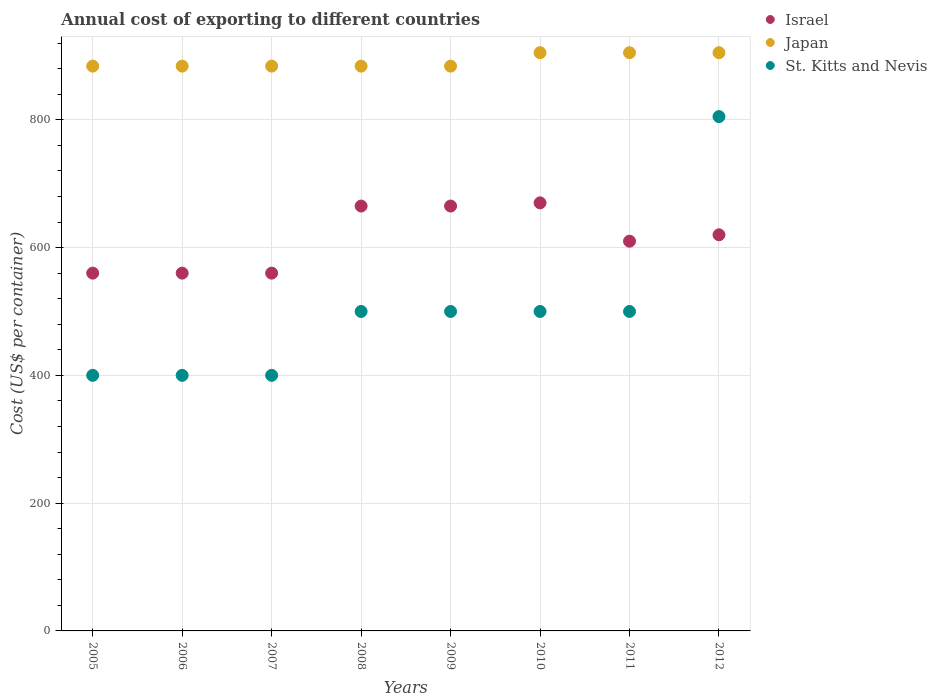What is the total annual cost of exporting in St. Kitts and Nevis in 2010?
Ensure brevity in your answer.  500. Across all years, what is the maximum total annual cost of exporting in Japan?
Your answer should be very brief. 905. Across all years, what is the minimum total annual cost of exporting in Japan?
Provide a short and direct response. 884. In which year was the total annual cost of exporting in Japan maximum?
Provide a succinct answer. 2010. What is the total total annual cost of exporting in St. Kitts and Nevis in the graph?
Offer a terse response. 4005. What is the difference between the total annual cost of exporting in Israel in 2009 and that in 2010?
Offer a very short reply. -5. What is the difference between the total annual cost of exporting in Japan in 2011 and the total annual cost of exporting in St. Kitts and Nevis in 2012?
Make the answer very short. 100. What is the average total annual cost of exporting in Israel per year?
Keep it short and to the point. 613.75. In the year 2009, what is the difference between the total annual cost of exporting in Israel and total annual cost of exporting in Japan?
Ensure brevity in your answer.  -219. Is the total annual cost of exporting in St. Kitts and Nevis in 2007 less than that in 2010?
Offer a terse response. Yes. Is the difference between the total annual cost of exporting in Israel in 2009 and 2011 greater than the difference between the total annual cost of exporting in Japan in 2009 and 2011?
Give a very brief answer. Yes. What is the difference between the highest and the lowest total annual cost of exporting in St. Kitts and Nevis?
Your response must be concise. 405. In how many years, is the total annual cost of exporting in Israel greater than the average total annual cost of exporting in Israel taken over all years?
Give a very brief answer. 4. Is it the case that in every year, the sum of the total annual cost of exporting in Japan and total annual cost of exporting in Israel  is greater than the total annual cost of exporting in St. Kitts and Nevis?
Your answer should be very brief. Yes. Does the total annual cost of exporting in St. Kitts and Nevis monotonically increase over the years?
Provide a short and direct response. No. How many dotlines are there?
Offer a very short reply. 3. Does the graph contain any zero values?
Keep it short and to the point. No. How many legend labels are there?
Make the answer very short. 3. How are the legend labels stacked?
Your response must be concise. Vertical. What is the title of the graph?
Your answer should be very brief. Annual cost of exporting to different countries. Does "South Africa" appear as one of the legend labels in the graph?
Offer a terse response. No. What is the label or title of the X-axis?
Your answer should be compact. Years. What is the label or title of the Y-axis?
Provide a succinct answer. Cost (US$ per container). What is the Cost (US$ per container) in Israel in 2005?
Provide a succinct answer. 560. What is the Cost (US$ per container) of Japan in 2005?
Your answer should be compact. 884. What is the Cost (US$ per container) in St. Kitts and Nevis in 2005?
Provide a short and direct response. 400. What is the Cost (US$ per container) in Israel in 2006?
Make the answer very short. 560. What is the Cost (US$ per container) of Japan in 2006?
Ensure brevity in your answer.  884. What is the Cost (US$ per container) in St. Kitts and Nevis in 2006?
Keep it short and to the point. 400. What is the Cost (US$ per container) in Israel in 2007?
Provide a short and direct response. 560. What is the Cost (US$ per container) in Japan in 2007?
Your answer should be very brief. 884. What is the Cost (US$ per container) in St. Kitts and Nevis in 2007?
Your answer should be very brief. 400. What is the Cost (US$ per container) in Israel in 2008?
Make the answer very short. 665. What is the Cost (US$ per container) in Japan in 2008?
Offer a very short reply. 884. What is the Cost (US$ per container) of Israel in 2009?
Keep it short and to the point. 665. What is the Cost (US$ per container) in Japan in 2009?
Offer a very short reply. 884. What is the Cost (US$ per container) of Israel in 2010?
Offer a terse response. 670. What is the Cost (US$ per container) in Japan in 2010?
Give a very brief answer. 905. What is the Cost (US$ per container) in St. Kitts and Nevis in 2010?
Provide a short and direct response. 500. What is the Cost (US$ per container) of Israel in 2011?
Make the answer very short. 610. What is the Cost (US$ per container) of Japan in 2011?
Make the answer very short. 905. What is the Cost (US$ per container) in Israel in 2012?
Provide a short and direct response. 620. What is the Cost (US$ per container) of Japan in 2012?
Ensure brevity in your answer.  905. What is the Cost (US$ per container) of St. Kitts and Nevis in 2012?
Give a very brief answer. 805. Across all years, what is the maximum Cost (US$ per container) of Israel?
Your response must be concise. 670. Across all years, what is the maximum Cost (US$ per container) in Japan?
Your answer should be very brief. 905. Across all years, what is the maximum Cost (US$ per container) of St. Kitts and Nevis?
Your answer should be compact. 805. Across all years, what is the minimum Cost (US$ per container) in Israel?
Your answer should be compact. 560. Across all years, what is the minimum Cost (US$ per container) of Japan?
Make the answer very short. 884. Across all years, what is the minimum Cost (US$ per container) of St. Kitts and Nevis?
Your answer should be very brief. 400. What is the total Cost (US$ per container) of Israel in the graph?
Provide a short and direct response. 4910. What is the total Cost (US$ per container) of Japan in the graph?
Your answer should be compact. 7135. What is the total Cost (US$ per container) in St. Kitts and Nevis in the graph?
Give a very brief answer. 4005. What is the difference between the Cost (US$ per container) of Israel in 2005 and that in 2006?
Your answer should be very brief. 0. What is the difference between the Cost (US$ per container) of Japan in 2005 and that in 2006?
Give a very brief answer. 0. What is the difference between the Cost (US$ per container) in St. Kitts and Nevis in 2005 and that in 2007?
Ensure brevity in your answer.  0. What is the difference between the Cost (US$ per container) of Israel in 2005 and that in 2008?
Your answer should be compact. -105. What is the difference between the Cost (US$ per container) of Japan in 2005 and that in 2008?
Give a very brief answer. 0. What is the difference between the Cost (US$ per container) of St. Kitts and Nevis in 2005 and that in 2008?
Your answer should be compact. -100. What is the difference between the Cost (US$ per container) of Israel in 2005 and that in 2009?
Your response must be concise. -105. What is the difference between the Cost (US$ per container) of St. Kitts and Nevis in 2005 and that in 2009?
Provide a succinct answer. -100. What is the difference between the Cost (US$ per container) of Israel in 2005 and that in 2010?
Your answer should be compact. -110. What is the difference between the Cost (US$ per container) of St. Kitts and Nevis in 2005 and that in 2010?
Make the answer very short. -100. What is the difference between the Cost (US$ per container) in St. Kitts and Nevis in 2005 and that in 2011?
Offer a very short reply. -100. What is the difference between the Cost (US$ per container) in Israel in 2005 and that in 2012?
Your response must be concise. -60. What is the difference between the Cost (US$ per container) in St. Kitts and Nevis in 2005 and that in 2012?
Give a very brief answer. -405. What is the difference between the Cost (US$ per container) in Israel in 2006 and that in 2007?
Make the answer very short. 0. What is the difference between the Cost (US$ per container) in Japan in 2006 and that in 2007?
Your response must be concise. 0. What is the difference between the Cost (US$ per container) of Israel in 2006 and that in 2008?
Provide a succinct answer. -105. What is the difference between the Cost (US$ per container) in Japan in 2006 and that in 2008?
Keep it short and to the point. 0. What is the difference between the Cost (US$ per container) in St. Kitts and Nevis in 2006 and that in 2008?
Offer a terse response. -100. What is the difference between the Cost (US$ per container) of Israel in 2006 and that in 2009?
Your response must be concise. -105. What is the difference between the Cost (US$ per container) of Japan in 2006 and that in 2009?
Offer a very short reply. 0. What is the difference between the Cost (US$ per container) in St. Kitts and Nevis in 2006 and that in 2009?
Offer a very short reply. -100. What is the difference between the Cost (US$ per container) of Israel in 2006 and that in 2010?
Keep it short and to the point. -110. What is the difference between the Cost (US$ per container) in St. Kitts and Nevis in 2006 and that in 2010?
Keep it short and to the point. -100. What is the difference between the Cost (US$ per container) in Israel in 2006 and that in 2011?
Your response must be concise. -50. What is the difference between the Cost (US$ per container) in St. Kitts and Nevis in 2006 and that in 2011?
Ensure brevity in your answer.  -100. What is the difference between the Cost (US$ per container) in Israel in 2006 and that in 2012?
Offer a terse response. -60. What is the difference between the Cost (US$ per container) in St. Kitts and Nevis in 2006 and that in 2012?
Give a very brief answer. -405. What is the difference between the Cost (US$ per container) in Israel in 2007 and that in 2008?
Ensure brevity in your answer.  -105. What is the difference between the Cost (US$ per container) in St. Kitts and Nevis in 2007 and that in 2008?
Make the answer very short. -100. What is the difference between the Cost (US$ per container) of Israel in 2007 and that in 2009?
Keep it short and to the point. -105. What is the difference between the Cost (US$ per container) of Japan in 2007 and that in 2009?
Your answer should be very brief. 0. What is the difference between the Cost (US$ per container) of St. Kitts and Nevis in 2007 and that in 2009?
Provide a succinct answer. -100. What is the difference between the Cost (US$ per container) in Israel in 2007 and that in 2010?
Offer a very short reply. -110. What is the difference between the Cost (US$ per container) of Japan in 2007 and that in 2010?
Make the answer very short. -21. What is the difference between the Cost (US$ per container) of St. Kitts and Nevis in 2007 and that in 2010?
Your answer should be compact. -100. What is the difference between the Cost (US$ per container) in Israel in 2007 and that in 2011?
Your answer should be compact. -50. What is the difference between the Cost (US$ per container) of Japan in 2007 and that in 2011?
Make the answer very short. -21. What is the difference between the Cost (US$ per container) of St. Kitts and Nevis in 2007 and that in 2011?
Make the answer very short. -100. What is the difference between the Cost (US$ per container) in Israel in 2007 and that in 2012?
Offer a very short reply. -60. What is the difference between the Cost (US$ per container) of St. Kitts and Nevis in 2007 and that in 2012?
Keep it short and to the point. -405. What is the difference between the Cost (US$ per container) of Israel in 2008 and that in 2009?
Your answer should be compact. 0. What is the difference between the Cost (US$ per container) in Japan in 2008 and that in 2009?
Your answer should be very brief. 0. What is the difference between the Cost (US$ per container) in St. Kitts and Nevis in 2008 and that in 2009?
Ensure brevity in your answer.  0. What is the difference between the Cost (US$ per container) of Israel in 2008 and that in 2010?
Offer a terse response. -5. What is the difference between the Cost (US$ per container) of Japan in 2008 and that in 2010?
Provide a short and direct response. -21. What is the difference between the Cost (US$ per container) of Japan in 2008 and that in 2011?
Keep it short and to the point. -21. What is the difference between the Cost (US$ per container) in St. Kitts and Nevis in 2008 and that in 2011?
Provide a succinct answer. 0. What is the difference between the Cost (US$ per container) of St. Kitts and Nevis in 2008 and that in 2012?
Keep it short and to the point. -305. What is the difference between the Cost (US$ per container) in Israel in 2009 and that in 2010?
Offer a terse response. -5. What is the difference between the Cost (US$ per container) in Japan in 2009 and that in 2010?
Keep it short and to the point. -21. What is the difference between the Cost (US$ per container) in Israel in 2009 and that in 2011?
Provide a succinct answer. 55. What is the difference between the Cost (US$ per container) in Japan in 2009 and that in 2011?
Give a very brief answer. -21. What is the difference between the Cost (US$ per container) of St. Kitts and Nevis in 2009 and that in 2011?
Provide a succinct answer. 0. What is the difference between the Cost (US$ per container) in Israel in 2009 and that in 2012?
Your answer should be very brief. 45. What is the difference between the Cost (US$ per container) of St. Kitts and Nevis in 2009 and that in 2012?
Give a very brief answer. -305. What is the difference between the Cost (US$ per container) of Israel in 2010 and that in 2011?
Provide a succinct answer. 60. What is the difference between the Cost (US$ per container) of Japan in 2010 and that in 2011?
Your answer should be compact. 0. What is the difference between the Cost (US$ per container) in Israel in 2010 and that in 2012?
Provide a short and direct response. 50. What is the difference between the Cost (US$ per container) of Japan in 2010 and that in 2012?
Provide a short and direct response. 0. What is the difference between the Cost (US$ per container) of St. Kitts and Nevis in 2010 and that in 2012?
Offer a terse response. -305. What is the difference between the Cost (US$ per container) of St. Kitts and Nevis in 2011 and that in 2012?
Your answer should be very brief. -305. What is the difference between the Cost (US$ per container) of Israel in 2005 and the Cost (US$ per container) of Japan in 2006?
Your answer should be compact. -324. What is the difference between the Cost (US$ per container) in Israel in 2005 and the Cost (US$ per container) in St. Kitts and Nevis in 2006?
Ensure brevity in your answer.  160. What is the difference between the Cost (US$ per container) of Japan in 2005 and the Cost (US$ per container) of St. Kitts and Nevis in 2006?
Your answer should be very brief. 484. What is the difference between the Cost (US$ per container) of Israel in 2005 and the Cost (US$ per container) of Japan in 2007?
Offer a very short reply. -324. What is the difference between the Cost (US$ per container) in Israel in 2005 and the Cost (US$ per container) in St. Kitts and Nevis in 2007?
Offer a terse response. 160. What is the difference between the Cost (US$ per container) in Japan in 2005 and the Cost (US$ per container) in St. Kitts and Nevis in 2007?
Ensure brevity in your answer.  484. What is the difference between the Cost (US$ per container) of Israel in 2005 and the Cost (US$ per container) of Japan in 2008?
Provide a short and direct response. -324. What is the difference between the Cost (US$ per container) of Israel in 2005 and the Cost (US$ per container) of St. Kitts and Nevis in 2008?
Provide a succinct answer. 60. What is the difference between the Cost (US$ per container) in Japan in 2005 and the Cost (US$ per container) in St. Kitts and Nevis in 2008?
Keep it short and to the point. 384. What is the difference between the Cost (US$ per container) of Israel in 2005 and the Cost (US$ per container) of Japan in 2009?
Your response must be concise. -324. What is the difference between the Cost (US$ per container) in Japan in 2005 and the Cost (US$ per container) in St. Kitts and Nevis in 2009?
Keep it short and to the point. 384. What is the difference between the Cost (US$ per container) in Israel in 2005 and the Cost (US$ per container) in Japan in 2010?
Ensure brevity in your answer.  -345. What is the difference between the Cost (US$ per container) of Japan in 2005 and the Cost (US$ per container) of St. Kitts and Nevis in 2010?
Your answer should be compact. 384. What is the difference between the Cost (US$ per container) of Israel in 2005 and the Cost (US$ per container) of Japan in 2011?
Ensure brevity in your answer.  -345. What is the difference between the Cost (US$ per container) in Israel in 2005 and the Cost (US$ per container) in St. Kitts and Nevis in 2011?
Keep it short and to the point. 60. What is the difference between the Cost (US$ per container) in Japan in 2005 and the Cost (US$ per container) in St. Kitts and Nevis in 2011?
Offer a terse response. 384. What is the difference between the Cost (US$ per container) in Israel in 2005 and the Cost (US$ per container) in Japan in 2012?
Offer a terse response. -345. What is the difference between the Cost (US$ per container) in Israel in 2005 and the Cost (US$ per container) in St. Kitts and Nevis in 2012?
Provide a short and direct response. -245. What is the difference between the Cost (US$ per container) of Japan in 2005 and the Cost (US$ per container) of St. Kitts and Nevis in 2012?
Ensure brevity in your answer.  79. What is the difference between the Cost (US$ per container) of Israel in 2006 and the Cost (US$ per container) of Japan in 2007?
Offer a very short reply. -324. What is the difference between the Cost (US$ per container) in Israel in 2006 and the Cost (US$ per container) in St. Kitts and Nevis in 2007?
Your answer should be very brief. 160. What is the difference between the Cost (US$ per container) of Japan in 2006 and the Cost (US$ per container) of St. Kitts and Nevis in 2007?
Provide a succinct answer. 484. What is the difference between the Cost (US$ per container) in Israel in 2006 and the Cost (US$ per container) in Japan in 2008?
Provide a succinct answer. -324. What is the difference between the Cost (US$ per container) in Japan in 2006 and the Cost (US$ per container) in St. Kitts and Nevis in 2008?
Make the answer very short. 384. What is the difference between the Cost (US$ per container) of Israel in 2006 and the Cost (US$ per container) of Japan in 2009?
Your answer should be compact. -324. What is the difference between the Cost (US$ per container) in Japan in 2006 and the Cost (US$ per container) in St. Kitts and Nevis in 2009?
Make the answer very short. 384. What is the difference between the Cost (US$ per container) of Israel in 2006 and the Cost (US$ per container) of Japan in 2010?
Keep it short and to the point. -345. What is the difference between the Cost (US$ per container) of Japan in 2006 and the Cost (US$ per container) of St. Kitts and Nevis in 2010?
Ensure brevity in your answer.  384. What is the difference between the Cost (US$ per container) of Israel in 2006 and the Cost (US$ per container) of Japan in 2011?
Give a very brief answer. -345. What is the difference between the Cost (US$ per container) in Israel in 2006 and the Cost (US$ per container) in St. Kitts and Nevis in 2011?
Your answer should be very brief. 60. What is the difference between the Cost (US$ per container) in Japan in 2006 and the Cost (US$ per container) in St. Kitts and Nevis in 2011?
Provide a succinct answer. 384. What is the difference between the Cost (US$ per container) of Israel in 2006 and the Cost (US$ per container) of Japan in 2012?
Offer a terse response. -345. What is the difference between the Cost (US$ per container) in Israel in 2006 and the Cost (US$ per container) in St. Kitts and Nevis in 2012?
Your answer should be very brief. -245. What is the difference between the Cost (US$ per container) in Japan in 2006 and the Cost (US$ per container) in St. Kitts and Nevis in 2012?
Your answer should be very brief. 79. What is the difference between the Cost (US$ per container) of Israel in 2007 and the Cost (US$ per container) of Japan in 2008?
Your response must be concise. -324. What is the difference between the Cost (US$ per container) of Japan in 2007 and the Cost (US$ per container) of St. Kitts and Nevis in 2008?
Provide a succinct answer. 384. What is the difference between the Cost (US$ per container) in Israel in 2007 and the Cost (US$ per container) in Japan in 2009?
Provide a short and direct response. -324. What is the difference between the Cost (US$ per container) in Japan in 2007 and the Cost (US$ per container) in St. Kitts and Nevis in 2009?
Your answer should be very brief. 384. What is the difference between the Cost (US$ per container) in Israel in 2007 and the Cost (US$ per container) in Japan in 2010?
Offer a very short reply. -345. What is the difference between the Cost (US$ per container) of Israel in 2007 and the Cost (US$ per container) of St. Kitts and Nevis in 2010?
Ensure brevity in your answer.  60. What is the difference between the Cost (US$ per container) of Japan in 2007 and the Cost (US$ per container) of St. Kitts and Nevis in 2010?
Provide a succinct answer. 384. What is the difference between the Cost (US$ per container) in Israel in 2007 and the Cost (US$ per container) in Japan in 2011?
Your response must be concise. -345. What is the difference between the Cost (US$ per container) in Japan in 2007 and the Cost (US$ per container) in St. Kitts and Nevis in 2011?
Ensure brevity in your answer.  384. What is the difference between the Cost (US$ per container) of Israel in 2007 and the Cost (US$ per container) of Japan in 2012?
Your answer should be very brief. -345. What is the difference between the Cost (US$ per container) in Israel in 2007 and the Cost (US$ per container) in St. Kitts and Nevis in 2012?
Your answer should be compact. -245. What is the difference between the Cost (US$ per container) of Japan in 2007 and the Cost (US$ per container) of St. Kitts and Nevis in 2012?
Provide a short and direct response. 79. What is the difference between the Cost (US$ per container) of Israel in 2008 and the Cost (US$ per container) of Japan in 2009?
Provide a short and direct response. -219. What is the difference between the Cost (US$ per container) in Israel in 2008 and the Cost (US$ per container) in St. Kitts and Nevis in 2009?
Offer a very short reply. 165. What is the difference between the Cost (US$ per container) of Japan in 2008 and the Cost (US$ per container) of St. Kitts and Nevis in 2009?
Offer a terse response. 384. What is the difference between the Cost (US$ per container) of Israel in 2008 and the Cost (US$ per container) of Japan in 2010?
Provide a short and direct response. -240. What is the difference between the Cost (US$ per container) in Israel in 2008 and the Cost (US$ per container) in St. Kitts and Nevis in 2010?
Offer a very short reply. 165. What is the difference between the Cost (US$ per container) of Japan in 2008 and the Cost (US$ per container) of St. Kitts and Nevis in 2010?
Offer a terse response. 384. What is the difference between the Cost (US$ per container) in Israel in 2008 and the Cost (US$ per container) in Japan in 2011?
Offer a very short reply. -240. What is the difference between the Cost (US$ per container) of Israel in 2008 and the Cost (US$ per container) of St. Kitts and Nevis in 2011?
Your answer should be very brief. 165. What is the difference between the Cost (US$ per container) of Japan in 2008 and the Cost (US$ per container) of St. Kitts and Nevis in 2011?
Your answer should be very brief. 384. What is the difference between the Cost (US$ per container) of Israel in 2008 and the Cost (US$ per container) of Japan in 2012?
Your answer should be compact. -240. What is the difference between the Cost (US$ per container) of Israel in 2008 and the Cost (US$ per container) of St. Kitts and Nevis in 2012?
Offer a terse response. -140. What is the difference between the Cost (US$ per container) in Japan in 2008 and the Cost (US$ per container) in St. Kitts and Nevis in 2012?
Your answer should be very brief. 79. What is the difference between the Cost (US$ per container) in Israel in 2009 and the Cost (US$ per container) in Japan in 2010?
Offer a very short reply. -240. What is the difference between the Cost (US$ per container) in Israel in 2009 and the Cost (US$ per container) in St. Kitts and Nevis in 2010?
Provide a short and direct response. 165. What is the difference between the Cost (US$ per container) in Japan in 2009 and the Cost (US$ per container) in St. Kitts and Nevis in 2010?
Your response must be concise. 384. What is the difference between the Cost (US$ per container) of Israel in 2009 and the Cost (US$ per container) of Japan in 2011?
Your response must be concise. -240. What is the difference between the Cost (US$ per container) of Israel in 2009 and the Cost (US$ per container) of St. Kitts and Nevis in 2011?
Keep it short and to the point. 165. What is the difference between the Cost (US$ per container) in Japan in 2009 and the Cost (US$ per container) in St. Kitts and Nevis in 2011?
Your answer should be compact. 384. What is the difference between the Cost (US$ per container) of Israel in 2009 and the Cost (US$ per container) of Japan in 2012?
Provide a succinct answer. -240. What is the difference between the Cost (US$ per container) in Israel in 2009 and the Cost (US$ per container) in St. Kitts and Nevis in 2012?
Offer a terse response. -140. What is the difference between the Cost (US$ per container) of Japan in 2009 and the Cost (US$ per container) of St. Kitts and Nevis in 2012?
Your response must be concise. 79. What is the difference between the Cost (US$ per container) in Israel in 2010 and the Cost (US$ per container) in Japan in 2011?
Offer a terse response. -235. What is the difference between the Cost (US$ per container) in Israel in 2010 and the Cost (US$ per container) in St. Kitts and Nevis in 2011?
Give a very brief answer. 170. What is the difference between the Cost (US$ per container) of Japan in 2010 and the Cost (US$ per container) of St. Kitts and Nevis in 2011?
Your answer should be compact. 405. What is the difference between the Cost (US$ per container) of Israel in 2010 and the Cost (US$ per container) of Japan in 2012?
Make the answer very short. -235. What is the difference between the Cost (US$ per container) of Israel in 2010 and the Cost (US$ per container) of St. Kitts and Nevis in 2012?
Keep it short and to the point. -135. What is the difference between the Cost (US$ per container) of Japan in 2010 and the Cost (US$ per container) of St. Kitts and Nevis in 2012?
Give a very brief answer. 100. What is the difference between the Cost (US$ per container) of Israel in 2011 and the Cost (US$ per container) of Japan in 2012?
Keep it short and to the point. -295. What is the difference between the Cost (US$ per container) in Israel in 2011 and the Cost (US$ per container) in St. Kitts and Nevis in 2012?
Your answer should be very brief. -195. What is the average Cost (US$ per container) in Israel per year?
Offer a very short reply. 613.75. What is the average Cost (US$ per container) of Japan per year?
Your answer should be very brief. 891.88. What is the average Cost (US$ per container) in St. Kitts and Nevis per year?
Ensure brevity in your answer.  500.62. In the year 2005, what is the difference between the Cost (US$ per container) of Israel and Cost (US$ per container) of Japan?
Your answer should be compact. -324. In the year 2005, what is the difference between the Cost (US$ per container) of Israel and Cost (US$ per container) of St. Kitts and Nevis?
Your answer should be very brief. 160. In the year 2005, what is the difference between the Cost (US$ per container) of Japan and Cost (US$ per container) of St. Kitts and Nevis?
Give a very brief answer. 484. In the year 2006, what is the difference between the Cost (US$ per container) of Israel and Cost (US$ per container) of Japan?
Your answer should be very brief. -324. In the year 2006, what is the difference between the Cost (US$ per container) of Israel and Cost (US$ per container) of St. Kitts and Nevis?
Offer a very short reply. 160. In the year 2006, what is the difference between the Cost (US$ per container) of Japan and Cost (US$ per container) of St. Kitts and Nevis?
Your response must be concise. 484. In the year 2007, what is the difference between the Cost (US$ per container) of Israel and Cost (US$ per container) of Japan?
Your answer should be very brief. -324. In the year 2007, what is the difference between the Cost (US$ per container) of Israel and Cost (US$ per container) of St. Kitts and Nevis?
Your answer should be very brief. 160. In the year 2007, what is the difference between the Cost (US$ per container) in Japan and Cost (US$ per container) in St. Kitts and Nevis?
Your answer should be compact. 484. In the year 2008, what is the difference between the Cost (US$ per container) of Israel and Cost (US$ per container) of Japan?
Your answer should be very brief. -219. In the year 2008, what is the difference between the Cost (US$ per container) in Israel and Cost (US$ per container) in St. Kitts and Nevis?
Your answer should be very brief. 165. In the year 2008, what is the difference between the Cost (US$ per container) in Japan and Cost (US$ per container) in St. Kitts and Nevis?
Offer a very short reply. 384. In the year 2009, what is the difference between the Cost (US$ per container) of Israel and Cost (US$ per container) of Japan?
Offer a very short reply. -219. In the year 2009, what is the difference between the Cost (US$ per container) of Israel and Cost (US$ per container) of St. Kitts and Nevis?
Keep it short and to the point. 165. In the year 2009, what is the difference between the Cost (US$ per container) in Japan and Cost (US$ per container) in St. Kitts and Nevis?
Offer a terse response. 384. In the year 2010, what is the difference between the Cost (US$ per container) in Israel and Cost (US$ per container) in Japan?
Your answer should be compact. -235. In the year 2010, what is the difference between the Cost (US$ per container) of Israel and Cost (US$ per container) of St. Kitts and Nevis?
Ensure brevity in your answer.  170. In the year 2010, what is the difference between the Cost (US$ per container) of Japan and Cost (US$ per container) of St. Kitts and Nevis?
Offer a very short reply. 405. In the year 2011, what is the difference between the Cost (US$ per container) of Israel and Cost (US$ per container) of Japan?
Your response must be concise. -295. In the year 2011, what is the difference between the Cost (US$ per container) in Israel and Cost (US$ per container) in St. Kitts and Nevis?
Ensure brevity in your answer.  110. In the year 2011, what is the difference between the Cost (US$ per container) of Japan and Cost (US$ per container) of St. Kitts and Nevis?
Provide a short and direct response. 405. In the year 2012, what is the difference between the Cost (US$ per container) of Israel and Cost (US$ per container) of Japan?
Provide a short and direct response. -285. In the year 2012, what is the difference between the Cost (US$ per container) of Israel and Cost (US$ per container) of St. Kitts and Nevis?
Offer a terse response. -185. In the year 2012, what is the difference between the Cost (US$ per container) in Japan and Cost (US$ per container) in St. Kitts and Nevis?
Provide a succinct answer. 100. What is the ratio of the Cost (US$ per container) of Israel in 2005 to that in 2007?
Offer a very short reply. 1. What is the ratio of the Cost (US$ per container) of Israel in 2005 to that in 2008?
Offer a terse response. 0.84. What is the ratio of the Cost (US$ per container) of Japan in 2005 to that in 2008?
Keep it short and to the point. 1. What is the ratio of the Cost (US$ per container) in St. Kitts and Nevis in 2005 to that in 2008?
Provide a short and direct response. 0.8. What is the ratio of the Cost (US$ per container) of Israel in 2005 to that in 2009?
Ensure brevity in your answer.  0.84. What is the ratio of the Cost (US$ per container) of Japan in 2005 to that in 2009?
Make the answer very short. 1. What is the ratio of the Cost (US$ per container) of Israel in 2005 to that in 2010?
Offer a very short reply. 0.84. What is the ratio of the Cost (US$ per container) in Japan in 2005 to that in 2010?
Provide a succinct answer. 0.98. What is the ratio of the Cost (US$ per container) in Israel in 2005 to that in 2011?
Provide a succinct answer. 0.92. What is the ratio of the Cost (US$ per container) in Japan in 2005 to that in 2011?
Keep it short and to the point. 0.98. What is the ratio of the Cost (US$ per container) of Israel in 2005 to that in 2012?
Offer a terse response. 0.9. What is the ratio of the Cost (US$ per container) of Japan in 2005 to that in 2012?
Provide a short and direct response. 0.98. What is the ratio of the Cost (US$ per container) in St. Kitts and Nevis in 2005 to that in 2012?
Keep it short and to the point. 0.5. What is the ratio of the Cost (US$ per container) of Israel in 2006 to that in 2008?
Ensure brevity in your answer.  0.84. What is the ratio of the Cost (US$ per container) in St. Kitts and Nevis in 2006 to that in 2008?
Your answer should be compact. 0.8. What is the ratio of the Cost (US$ per container) in Israel in 2006 to that in 2009?
Offer a terse response. 0.84. What is the ratio of the Cost (US$ per container) in Japan in 2006 to that in 2009?
Provide a short and direct response. 1. What is the ratio of the Cost (US$ per container) of St. Kitts and Nevis in 2006 to that in 2009?
Give a very brief answer. 0.8. What is the ratio of the Cost (US$ per container) in Israel in 2006 to that in 2010?
Ensure brevity in your answer.  0.84. What is the ratio of the Cost (US$ per container) of Japan in 2006 to that in 2010?
Offer a very short reply. 0.98. What is the ratio of the Cost (US$ per container) in St. Kitts and Nevis in 2006 to that in 2010?
Provide a succinct answer. 0.8. What is the ratio of the Cost (US$ per container) in Israel in 2006 to that in 2011?
Your response must be concise. 0.92. What is the ratio of the Cost (US$ per container) of Japan in 2006 to that in 2011?
Offer a terse response. 0.98. What is the ratio of the Cost (US$ per container) of St. Kitts and Nevis in 2006 to that in 2011?
Offer a terse response. 0.8. What is the ratio of the Cost (US$ per container) in Israel in 2006 to that in 2012?
Offer a very short reply. 0.9. What is the ratio of the Cost (US$ per container) in Japan in 2006 to that in 2012?
Ensure brevity in your answer.  0.98. What is the ratio of the Cost (US$ per container) in St. Kitts and Nevis in 2006 to that in 2012?
Provide a short and direct response. 0.5. What is the ratio of the Cost (US$ per container) in Israel in 2007 to that in 2008?
Make the answer very short. 0.84. What is the ratio of the Cost (US$ per container) of Japan in 2007 to that in 2008?
Give a very brief answer. 1. What is the ratio of the Cost (US$ per container) of St. Kitts and Nevis in 2007 to that in 2008?
Keep it short and to the point. 0.8. What is the ratio of the Cost (US$ per container) in Israel in 2007 to that in 2009?
Provide a short and direct response. 0.84. What is the ratio of the Cost (US$ per container) of St. Kitts and Nevis in 2007 to that in 2009?
Offer a terse response. 0.8. What is the ratio of the Cost (US$ per container) in Israel in 2007 to that in 2010?
Give a very brief answer. 0.84. What is the ratio of the Cost (US$ per container) of Japan in 2007 to that in 2010?
Offer a very short reply. 0.98. What is the ratio of the Cost (US$ per container) in Israel in 2007 to that in 2011?
Give a very brief answer. 0.92. What is the ratio of the Cost (US$ per container) in Japan in 2007 to that in 2011?
Your answer should be very brief. 0.98. What is the ratio of the Cost (US$ per container) in St. Kitts and Nevis in 2007 to that in 2011?
Your answer should be very brief. 0.8. What is the ratio of the Cost (US$ per container) in Israel in 2007 to that in 2012?
Provide a succinct answer. 0.9. What is the ratio of the Cost (US$ per container) of Japan in 2007 to that in 2012?
Ensure brevity in your answer.  0.98. What is the ratio of the Cost (US$ per container) in St. Kitts and Nevis in 2007 to that in 2012?
Ensure brevity in your answer.  0.5. What is the ratio of the Cost (US$ per container) in Israel in 2008 to that in 2009?
Your answer should be compact. 1. What is the ratio of the Cost (US$ per container) in Japan in 2008 to that in 2010?
Offer a very short reply. 0.98. What is the ratio of the Cost (US$ per container) of Israel in 2008 to that in 2011?
Your answer should be compact. 1.09. What is the ratio of the Cost (US$ per container) of Japan in 2008 to that in 2011?
Offer a very short reply. 0.98. What is the ratio of the Cost (US$ per container) in St. Kitts and Nevis in 2008 to that in 2011?
Offer a very short reply. 1. What is the ratio of the Cost (US$ per container) in Israel in 2008 to that in 2012?
Give a very brief answer. 1.07. What is the ratio of the Cost (US$ per container) of Japan in 2008 to that in 2012?
Your answer should be compact. 0.98. What is the ratio of the Cost (US$ per container) in St. Kitts and Nevis in 2008 to that in 2012?
Give a very brief answer. 0.62. What is the ratio of the Cost (US$ per container) in Israel in 2009 to that in 2010?
Your answer should be compact. 0.99. What is the ratio of the Cost (US$ per container) in Japan in 2009 to that in 2010?
Provide a succinct answer. 0.98. What is the ratio of the Cost (US$ per container) in St. Kitts and Nevis in 2009 to that in 2010?
Ensure brevity in your answer.  1. What is the ratio of the Cost (US$ per container) of Israel in 2009 to that in 2011?
Your response must be concise. 1.09. What is the ratio of the Cost (US$ per container) of Japan in 2009 to that in 2011?
Your answer should be very brief. 0.98. What is the ratio of the Cost (US$ per container) of St. Kitts and Nevis in 2009 to that in 2011?
Provide a short and direct response. 1. What is the ratio of the Cost (US$ per container) of Israel in 2009 to that in 2012?
Provide a succinct answer. 1.07. What is the ratio of the Cost (US$ per container) in Japan in 2009 to that in 2012?
Provide a short and direct response. 0.98. What is the ratio of the Cost (US$ per container) of St. Kitts and Nevis in 2009 to that in 2012?
Provide a succinct answer. 0.62. What is the ratio of the Cost (US$ per container) of Israel in 2010 to that in 2011?
Keep it short and to the point. 1.1. What is the ratio of the Cost (US$ per container) of Japan in 2010 to that in 2011?
Offer a terse response. 1. What is the ratio of the Cost (US$ per container) in St. Kitts and Nevis in 2010 to that in 2011?
Provide a succinct answer. 1. What is the ratio of the Cost (US$ per container) of Israel in 2010 to that in 2012?
Provide a succinct answer. 1.08. What is the ratio of the Cost (US$ per container) in Japan in 2010 to that in 2012?
Your answer should be compact. 1. What is the ratio of the Cost (US$ per container) of St. Kitts and Nevis in 2010 to that in 2012?
Your answer should be compact. 0.62. What is the ratio of the Cost (US$ per container) of Israel in 2011 to that in 2012?
Your response must be concise. 0.98. What is the ratio of the Cost (US$ per container) of St. Kitts and Nevis in 2011 to that in 2012?
Give a very brief answer. 0.62. What is the difference between the highest and the second highest Cost (US$ per container) of Israel?
Provide a succinct answer. 5. What is the difference between the highest and the second highest Cost (US$ per container) in Japan?
Ensure brevity in your answer.  0. What is the difference between the highest and the second highest Cost (US$ per container) of St. Kitts and Nevis?
Provide a short and direct response. 305. What is the difference between the highest and the lowest Cost (US$ per container) in Israel?
Give a very brief answer. 110. What is the difference between the highest and the lowest Cost (US$ per container) of Japan?
Provide a succinct answer. 21. What is the difference between the highest and the lowest Cost (US$ per container) of St. Kitts and Nevis?
Offer a terse response. 405. 